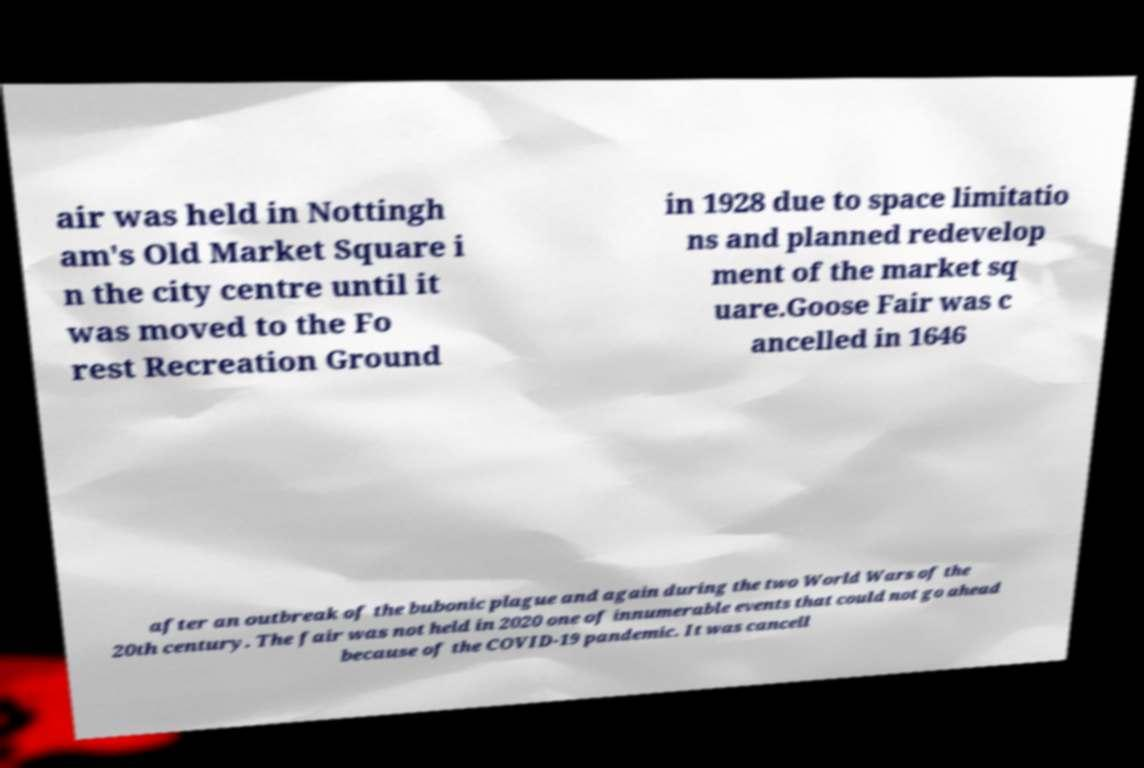For documentation purposes, I need the text within this image transcribed. Could you provide that? air was held in Nottingh am's Old Market Square i n the city centre until it was moved to the Fo rest Recreation Ground in 1928 due to space limitatio ns and planned redevelop ment of the market sq uare.Goose Fair was c ancelled in 1646 after an outbreak of the bubonic plague and again during the two World Wars of the 20th century. The fair was not held in 2020 one of innumerable events that could not go ahead because of the COVID-19 pandemic. It was cancell 